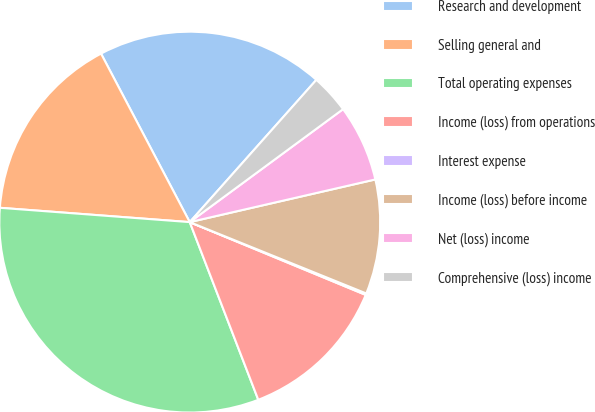Convert chart. <chart><loc_0><loc_0><loc_500><loc_500><pie_chart><fcel>Research and development<fcel>Selling general and<fcel>Total operating expenses<fcel>Income (loss) from operations<fcel>Interest expense<fcel>Income (loss) before income<fcel>Net (loss) income<fcel>Comprehensive (loss) income<nl><fcel>19.29%<fcel>16.09%<fcel>32.06%<fcel>12.9%<fcel>0.13%<fcel>9.71%<fcel>6.51%<fcel>3.32%<nl></chart> 